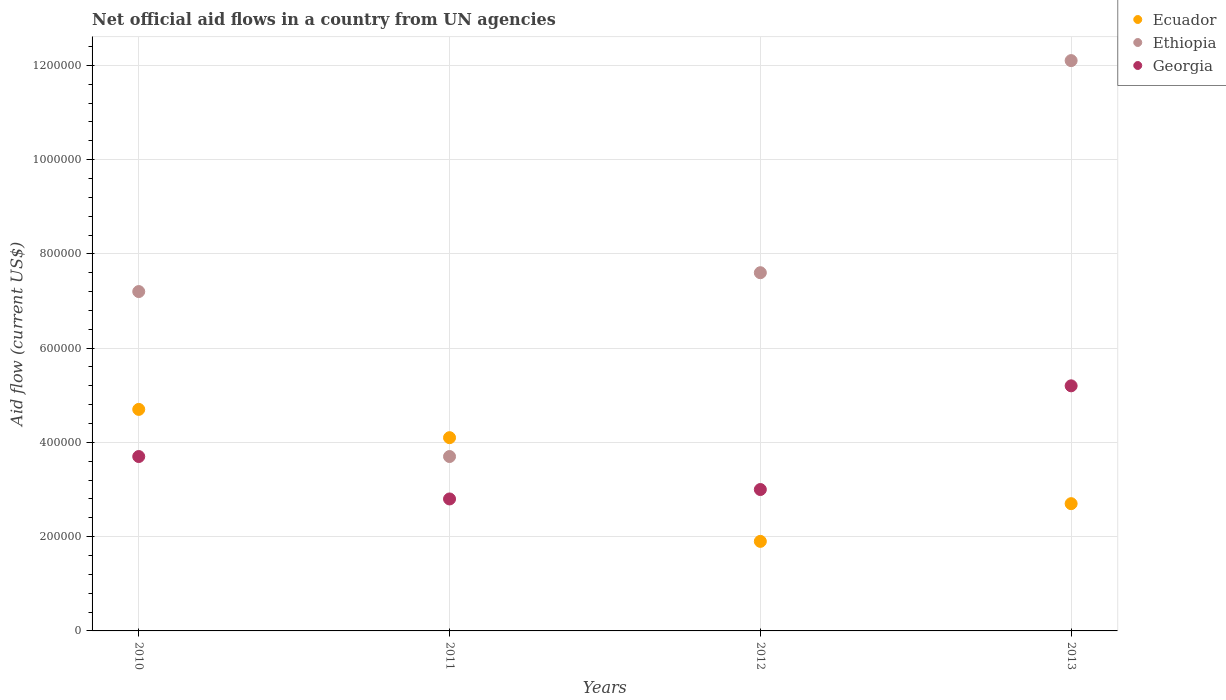How many different coloured dotlines are there?
Keep it short and to the point. 3. What is the net official aid flow in Ethiopia in 2012?
Keep it short and to the point. 7.60e+05. Across all years, what is the maximum net official aid flow in Georgia?
Your answer should be very brief. 5.20e+05. Across all years, what is the minimum net official aid flow in Ethiopia?
Your answer should be compact. 3.70e+05. In which year was the net official aid flow in Ecuador minimum?
Offer a terse response. 2012. What is the total net official aid flow in Ethiopia in the graph?
Ensure brevity in your answer.  3.06e+06. What is the difference between the net official aid flow in Georgia in 2010 and that in 2011?
Give a very brief answer. 9.00e+04. What is the difference between the net official aid flow in Georgia in 2013 and the net official aid flow in Ethiopia in 2010?
Ensure brevity in your answer.  -2.00e+05. What is the average net official aid flow in Georgia per year?
Make the answer very short. 3.68e+05. In the year 2013, what is the difference between the net official aid flow in Ethiopia and net official aid flow in Georgia?
Your answer should be compact. 6.90e+05. What is the ratio of the net official aid flow in Ecuador in 2011 to that in 2012?
Provide a succinct answer. 2.16. Is the difference between the net official aid flow in Ethiopia in 2010 and 2013 greater than the difference between the net official aid flow in Georgia in 2010 and 2013?
Your answer should be compact. No. What is the difference between the highest and the lowest net official aid flow in Ethiopia?
Offer a terse response. 8.40e+05. Does the net official aid flow in Ethiopia monotonically increase over the years?
Offer a terse response. No. How many dotlines are there?
Your answer should be very brief. 3. Does the graph contain any zero values?
Offer a terse response. No. Where does the legend appear in the graph?
Offer a terse response. Top right. How are the legend labels stacked?
Provide a short and direct response. Vertical. What is the title of the graph?
Provide a succinct answer. Net official aid flows in a country from UN agencies. Does "Latvia" appear as one of the legend labels in the graph?
Provide a short and direct response. No. What is the label or title of the X-axis?
Offer a terse response. Years. What is the Aid flow (current US$) in Ethiopia in 2010?
Ensure brevity in your answer.  7.20e+05. What is the Aid flow (current US$) of Georgia in 2010?
Provide a short and direct response. 3.70e+05. What is the Aid flow (current US$) in Ethiopia in 2011?
Offer a terse response. 3.70e+05. What is the Aid flow (current US$) in Ecuador in 2012?
Provide a succinct answer. 1.90e+05. What is the Aid flow (current US$) in Ethiopia in 2012?
Your answer should be very brief. 7.60e+05. What is the Aid flow (current US$) of Ethiopia in 2013?
Offer a very short reply. 1.21e+06. What is the Aid flow (current US$) of Georgia in 2013?
Your answer should be compact. 5.20e+05. Across all years, what is the maximum Aid flow (current US$) of Ethiopia?
Keep it short and to the point. 1.21e+06. Across all years, what is the maximum Aid flow (current US$) of Georgia?
Offer a very short reply. 5.20e+05. Across all years, what is the minimum Aid flow (current US$) of Ecuador?
Provide a succinct answer. 1.90e+05. Across all years, what is the minimum Aid flow (current US$) in Ethiopia?
Offer a terse response. 3.70e+05. What is the total Aid flow (current US$) in Ecuador in the graph?
Your answer should be very brief. 1.34e+06. What is the total Aid flow (current US$) in Ethiopia in the graph?
Provide a succinct answer. 3.06e+06. What is the total Aid flow (current US$) of Georgia in the graph?
Make the answer very short. 1.47e+06. What is the difference between the Aid flow (current US$) in Georgia in 2010 and that in 2011?
Provide a succinct answer. 9.00e+04. What is the difference between the Aid flow (current US$) in Georgia in 2010 and that in 2012?
Provide a succinct answer. 7.00e+04. What is the difference between the Aid flow (current US$) in Ecuador in 2010 and that in 2013?
Offer a terse response. 2.00e+05. What is the difference between the Aid flow (current US$) in Ethiopia in 2010 and that in 2013?
Provide a short and direct response. -4.90e+05. What is the difference between the Aid flow (current US$) in Ecuador in 2011 and that in 2012?
Keep it short and to the point. 2.20e+05. What is the difference between the Aid flow (current US$) in Ethiopia in 2011 and that in 2012?
Make the answer very short. -3.90e+05. What is the difference between the Aid flow (current US$) in Georgia in 2011 and that in 2012?
Offer a terse response. -2.00e+04. What is the difference between the Aid flow (current US$) in Ecuador in 2011 and that in 2013?
Your response must be concise. 1.40e+05. What is the difference between the Aid flow (current US$) of Ethiopia in 2011 and that in 2013?
Give a very brief answer. -8.40e+05. What is the difference between the Aid flow (current US$) of Ethiopia in 2012 and that in 2013?
Your response must be concise. -4.50e+05. What is the difference between the Aid flow (current US$) of Ethiopia in 2010 and the Aid flow (current US$) of Georgia in 2011?
Offer a very short reply. 4.40e+05. What is the difference between the Aid flow (current US$) of Ecuador in 2010 and the Aid flow (current US$) of Ethiopia in 2012?
Your response must be concise. -2.90e+05. What is the difference between the Aid flow (current US$) in Ecuador in 2010 and the Aid flow (current US$) in Ethiopia in 2013?
Offer a terse response. -7.40e+05. What is the difference between the Aid flow (current US$) in Ecuador in 2010 and the Aid flow (current US$) in Georgia in 2013?
Give a very brief answer. -5.00e+04. What is the difference between the Aid flow (current US$) in Ethiopia in 2010 and the Aid flow (current US$) in Georgia in 2013?
Offer a very short reply. 2.00e+05. What is the difference between the Aid flow (current US$) of Ecuador in 2011 and the Aid flow (current US$) of Ethiopia in 2012?
Your response must be concise. -3.50e+05. What is the difference between the Aid flow (current US$) of Ecuador in 2011 and the Aid flow (current US$) of Georgia in 2012?
Offer a terse response. 1.10e+05. What is the difference between the Aid flow (current US$) in Ecuador in 2011 and the Aid flow (current US$) in Ethiopia in 2013?
Keep it short and to the point. -8.00e+05. What is the difference between the Aid flow (current US$) in Ecuador in 2011 and the Aid flow (current US$) in Georgia in 2013?
Provide a short and direct response. -1.10e+05. What is the difference between the Aid flow (current US$) of Ecuador in 2012 and the Aid flow (current US$) of Ethiopia in 2013?
Provide a succinct answer. -1.02e+06. What is the difference between the Aid flow (current US$) in Ecuador in 2012 and the Aid flow (current US$) in Georgia in 2013?
Offer a terse response. -3.30e+05. What is the difference between the Aid flow (current US$) in Ethiopia in 2012 and the Aid flow (current US$) in Georgia in 2013?
Keep it short and to the point. 2.40e+05. What is the average Aid flow (current US$) in Ecuador per year?
Make the answer very short. 3.35e+05. What is the average Aid flow (current US$) in Ethiopia per year?
Your answer should be very brief. 7.65e+05. What is the average Aid flow (current US$) in Georgia per year?
Offer a very short reply. 3.68e+05. In the year 2010, what is the difference between the Aid flow (current US$) of Ecuador and Aid flow (current US$) of Ethiopia?
Offer a very short reply. -2.50e+05. In the year 2010, what is the difference between the Aid flow (current US$) in Ecuador and Aid flow (current US$) in Georgia?
Provide a short and direct response. 1.00e+05. In the year 2010, what is the difference between the Aid flow (current US$) in Ethiopia and Aid flow (current US$) in Georgia?
Your answer should be very brief. 3.50e+05. In the year 2011, what is the difference between the Aid flow (current US$) of Ecuador and Aid flow (current US$) of Georgia?
Ensure brevity in your answer.  1.30e+05. In the year 2012, what is the difference between the Aid flow (current US$) in Ecuador and Aid flow (current US$) in Ethiopia?
Your response must be concise. -5.70e+05. In the year 2012, what is the difference between the Aid flow (current US$) in Ethiopia and Aid flow (current US$) in Georgia?
Make the answer very short. 4.60e+05. In the year 2013, what is the difference between the Aid flow (current US$) of Ecuador and Aid flow (current US$) of Ethiopia?
Your answer should be very brief. -9.40e+05. In the year 2013, what is the difference between the Aid flow (current US$) in Ethiopia and Aid flow (current US$) in Georgia?
Your answer should be very brief. 6.90e+05. What is the ratio of the Aid flow (current US$) in Ecuador in 2010 to that in 2011?
Keep it short and to the point. 1.15. What is the ratio of the Aid flow (current US$) in Ethiopia in 2010 to that in 2011?
Offer a very short reply. 1.95. What is the ratio of the Aid flow (current US$) in Georgia in 2010 to that in 2011?
Your answer should be very brief. 1.32. What is the ratio of the Aid flow (current US$) of Ecuador in 2010 to that in 2012?
Your response must be concise. 2.47. What is the ratio of the Aid flow (current US$) in Georgia in 2010 to that in 2012?
Give a very brief answer. 1.23. What is the ratio of the Aid flow (current US$) in Ecuador in 2010 to that in 2013?
Ensure brevity in your answer.  1.74. What is the ratio of the Aid flow (current US$) of Ethiopia in 2010 to that in 2013?
Make the answer very short. 0.59. What is the ratio of the Aid flow (current US$) of Georgia in 2010 to that in 2013?
Offer a very short reply. 0.71. What is the ratio of the Aid flow (current US$) in Ecuador in 2011 to that in 2012?
Your response must be concise. 2.16. What is the ratio of the Aid flow (current US$) in Ethiopia in 2011 to that in 2012?
Make the answer very short. 0.49. What is the ratio of the Aid flow (current US$) in Ecuador in 2011 to that in 2013?
Ensure brevity in your answer.  1.52. What is the ratio of the Aid flow (current US$) in Ethiopia in 2011 to that in 2013?
Your answer should be very brief. 0.31. What is the ratio of the Aid flow (current US$) in Georgia in 2011 to that in 2013?
Make the answer very short. 0.54. What is the ratio of the Aid flow (current US$) in Ecuador in 2012 to that in 2013?
Provide a succinct answer. 0.7. What is the ratio of the Aid flow (current US$) of Ethiopia in 2012 to that in 2013?
Give a very brief answer. 0.63. What is the ratio of the Aid flow (current US$) in Georgia in 2012 to that in 2013?
Your answer should be compact. 0.58. What is the difference between the highest and the second highest Aid flow (current US$) of Ecuador?
Your answer should be compact. 6.00e+04. What is the difference between the highest and the second highest Aid flow (current US$) of Ethiopia?
Your answer should be very brief. 4.50e+05. What is the difference between the highest and the lowest Aid flow (current US$) in Ethiopia?
Your response must be concise. 8.40e+05. 